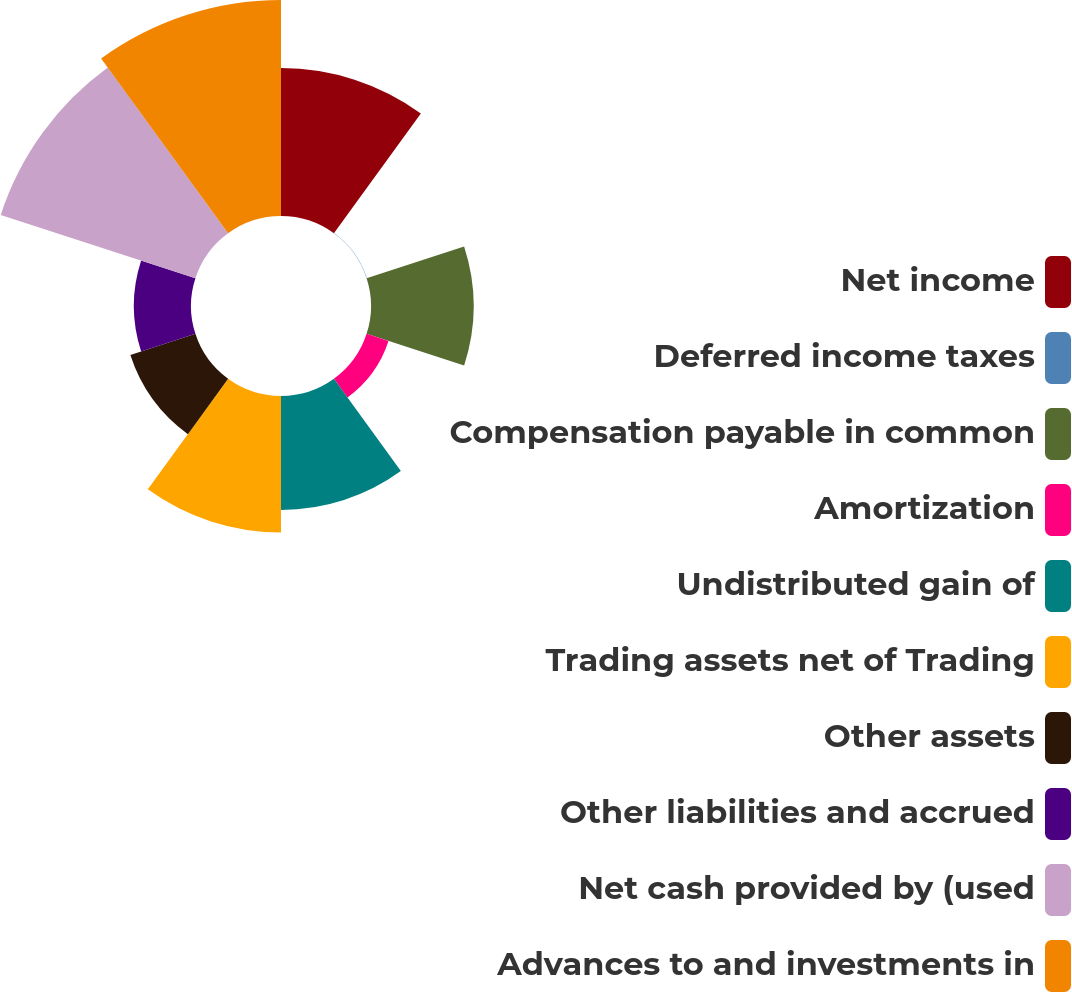Convert chart. <chart><loc_0><loc_0><loc_500><loc_500><pie_chart><fcel>Net income<fcel>Deferred income taxes<fcel>Compensation payable in common<fcel>Amortization<fcel>Undistributed gain of<fcel>Trading assets net of Trading<fcel>Other assets<fcel>Other liabilities and accrued<fcel>Net cash provided by (used<fcel>Advances to and investments in<nl><fcel>13.82%<fcel>0.03%<fcel>9.58%<fcel>2.15%<fcel>10.64%<fcel>12.76%<fcel>6.39%<fcel>5.33%<fcel>19.12%<fcel>20.18%<nl></chart> 